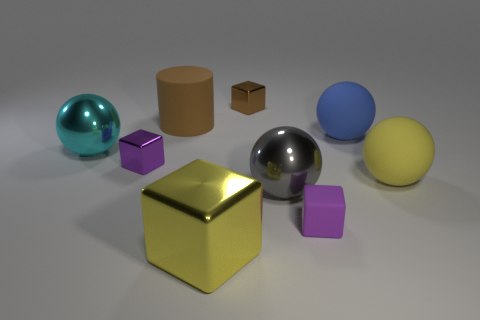Subtract all small cubes. How many cubes are left? 1 Subtract 4 spheres. How many spheres are left? 0 Subtract all gray balls. How many balls are left? 3 Subtract all purple cylinders. Subtract all blue balls. How many cylinders are left? 1 Subtract all green spheres. How many brown blocks are left? 1 Subtract all tiny cyan matte cylinders. Subtract all big matte objects. How many objects are left? 6 Add 7 yellow matte balls. How many yellow matte balls are left? 8 Add 4 small red objects. How many small red objects exist? 4 Subtract 0 blue blocks. How many objects are left? 9 Subtract all cylinders. How many objects are left? 8 